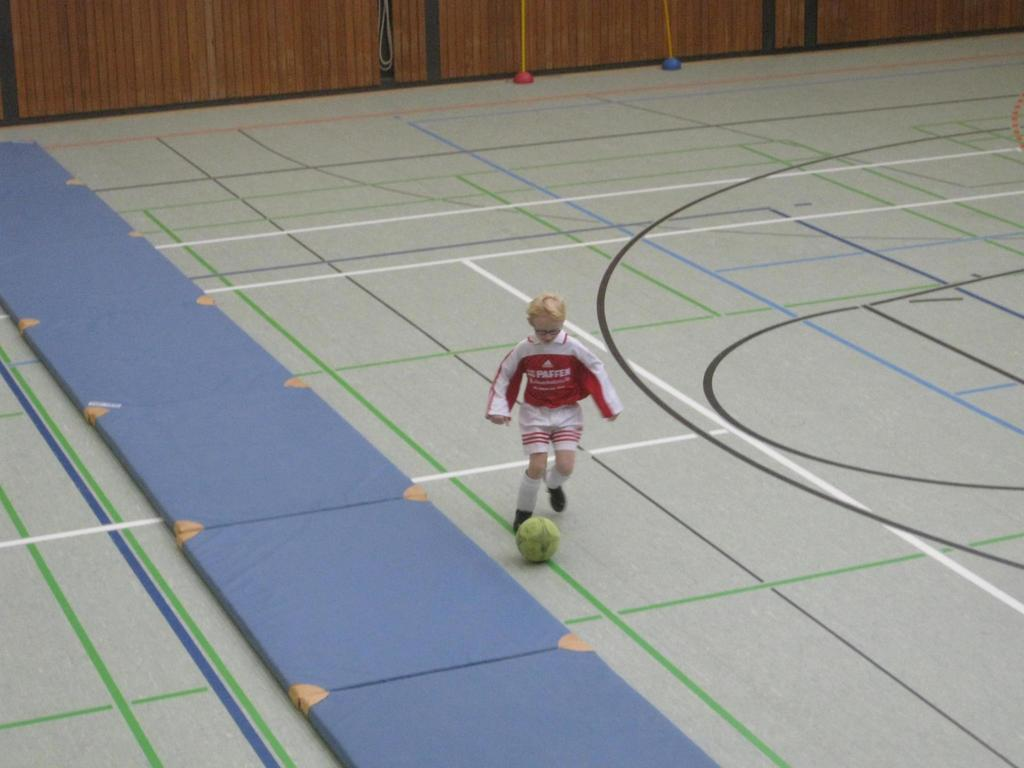<image>
Create a compact narrative representing the image presented. Man that is playing soccer in an empty indoor arena, his shirt says Paffen. 